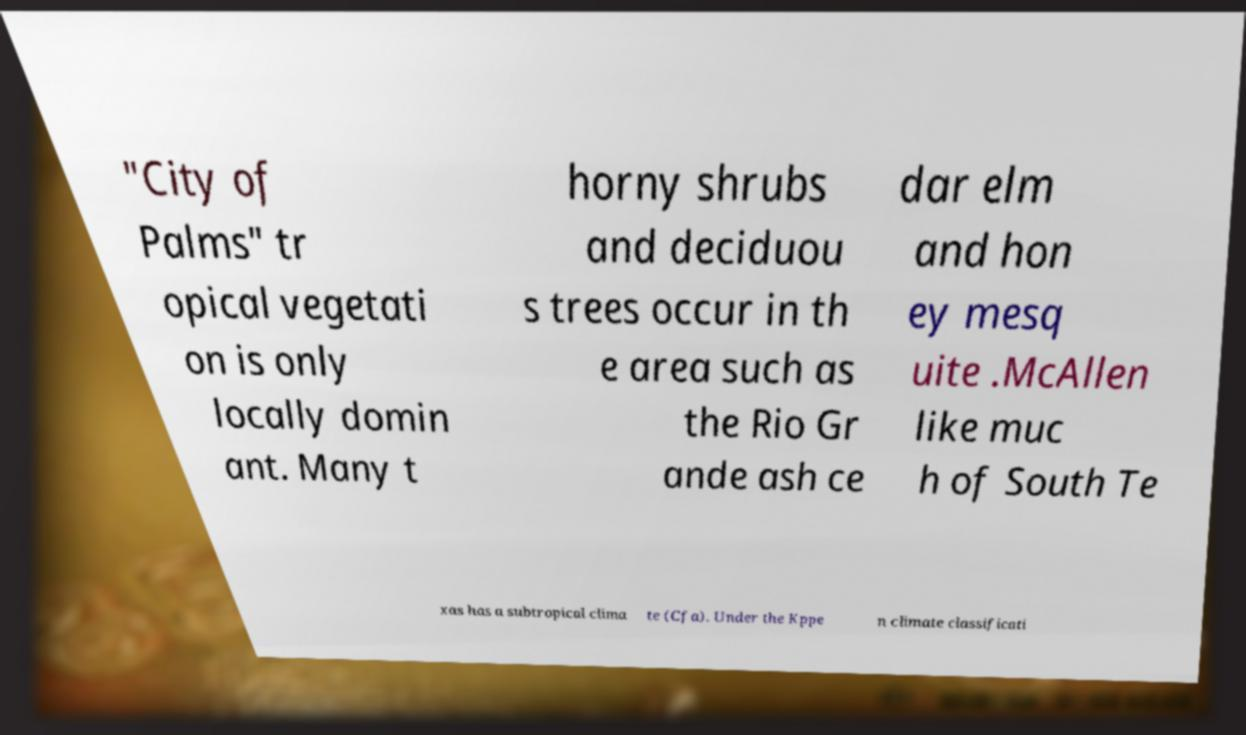Could you extract and type out the text from this image? "City of Palms" tr opical vegetati on is only locally domin ant. Many t horny shrubs and deciduou s trees occur in th e area such as the Rio Gr ande ash ce dar elm and hon ey mesq uite .McAllen like muc h of South Te xas has a subtropical clima te (Cfa). Under the Kppe n climate classificati 